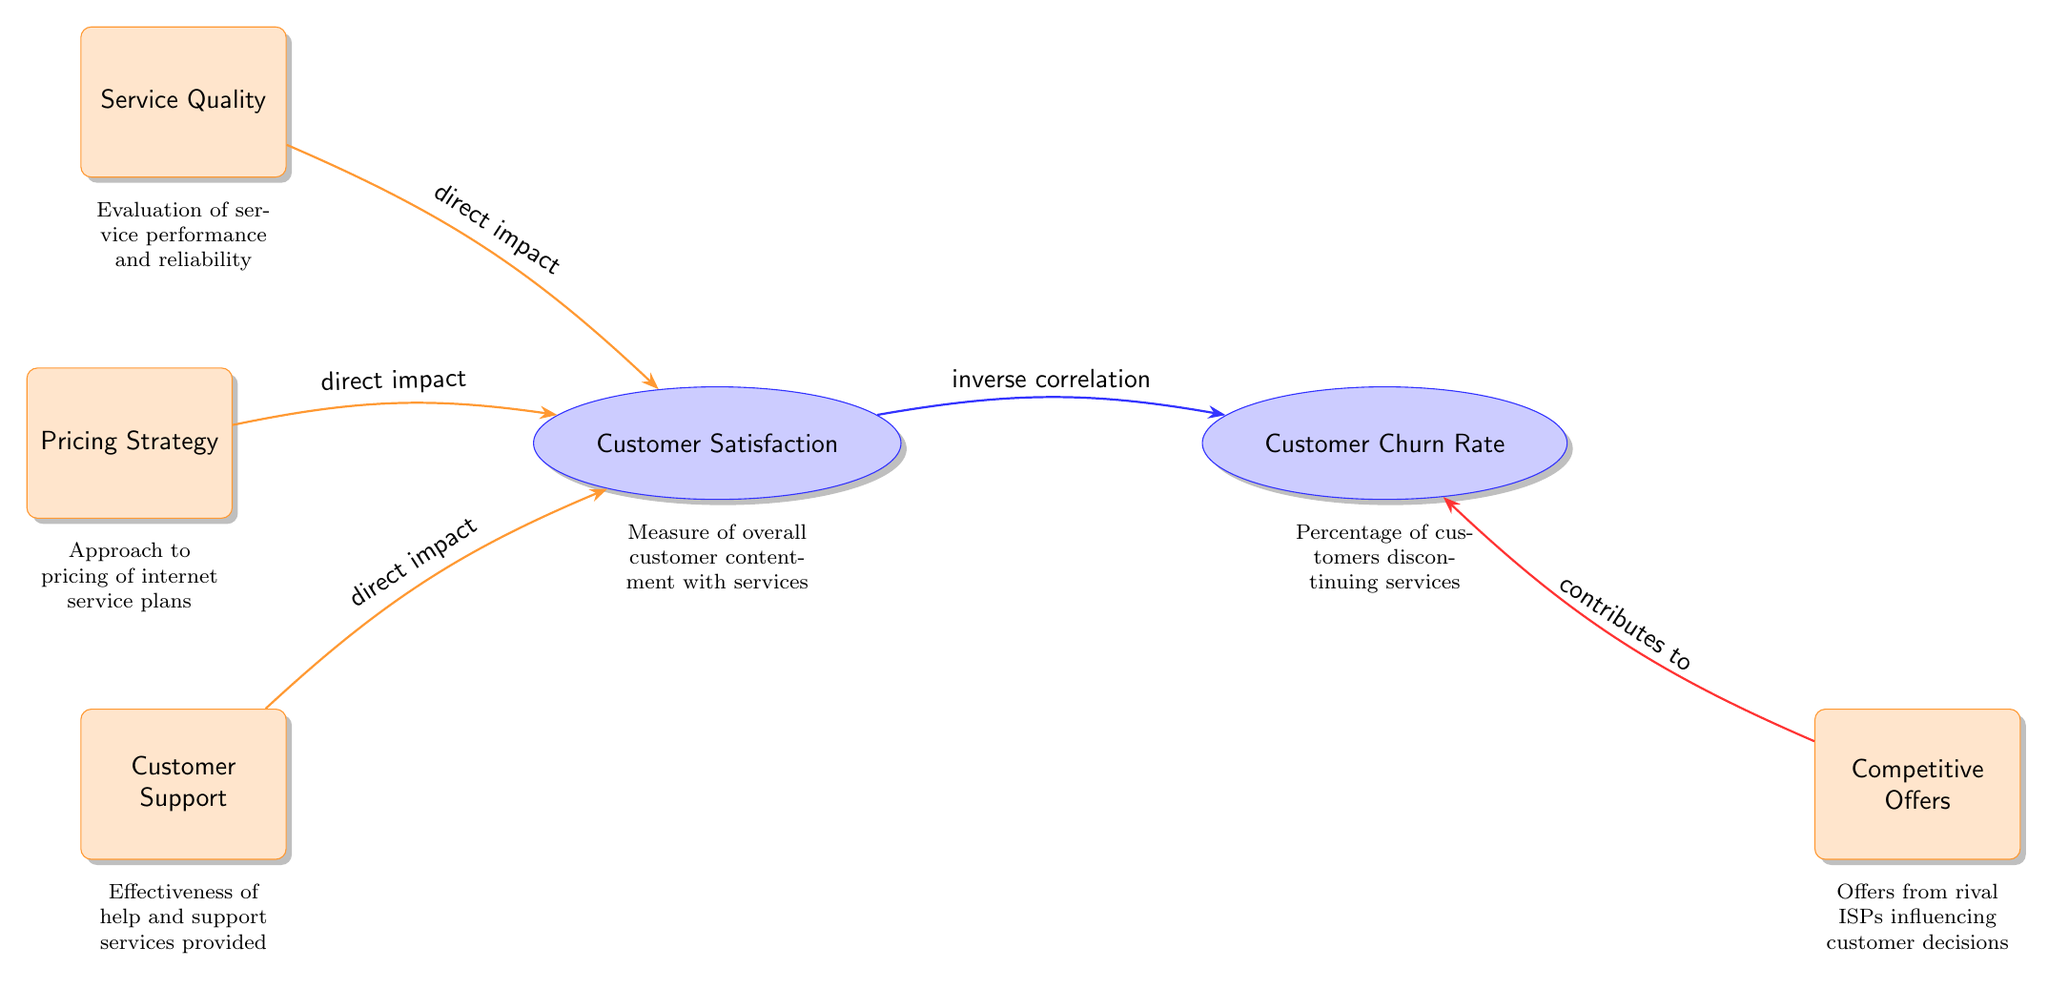What are the main factors affecting Customer Satisfaction? The diagram indicates three main factors that have a direct impact on Customer Satisfaction: Service Quality, Pricing Strategy, and Customer Support. These factors are positioned as direct arrows leading towards the Customer Satisfaction node.
Answer: Service Quality, Pricing Strategy, Customer Support How does Customer Satisfaction relate to Customer Churn Rate? The diagram shows a direct arrow labeled "inverse correlation" that flows from the Customer Satisfaction node to the Customer Churn Rate node. This indicates that as Customer Satisfaction increases, Customer Churn Rate decreases.
Answer: Inverse correlation What relationships exist between factors and Customer Churn Rate? The diagram indicates that Customer Satisfaction affects Customer Churn Rate inversely and that Competitive Offers contribute to increasing the Customer Churn Rate. However, there are no other factors directly pointing to Customer Churn Rate in the diagram.
Answer: Competitive Offers How many main nodes are present in this diagram? By examining the diagram, we identify two main nodes: Customer Satisfaction and Customer Churn Rate, thus indicating the count of main nodes present.
Answer: 2 Which factor has a direct impact on Customer Satisfaction besides Service Quality? The diagram identifies Pricing Strategy and Customer Support, in addition to Service Quality, as factors that directly impact Customer Satisfaction. Therefore, the question can be answered by mentioning either of the other two factors.
Answer: Pricing Strategy, Customer Support What is the significance of Competitive Offers in this diagram? Competitive Offers are shown to contribute to Customer Churn Rate, indicating that offers from rival ISPs can influence customer decisions to leave the service provider. This illustrates an important aspect of competition that the ISP executive should consider.
Answer: Contributes to churn Which node has more influencing factors leading to it, Customer Satisfaction or Customer Churn Rate? By analyzing the diagram, Customer Satisfaction has three influencing factors (Service Quality, Pricing Strategy, and Customer Support), whereas Customer Churn Rate is influenced only by Competitive Offers. Thus, Customer Satisfaction has more factors leading to it.
Answer: Customer Satisfaction What impact does Customer Support have? The diagram notes that Customer Support has a direct impact on Customer Satisfaction, indicating that effective help and support services positively influence customer contentment with the services provided.
Answer: Direct impact on satisfaction 